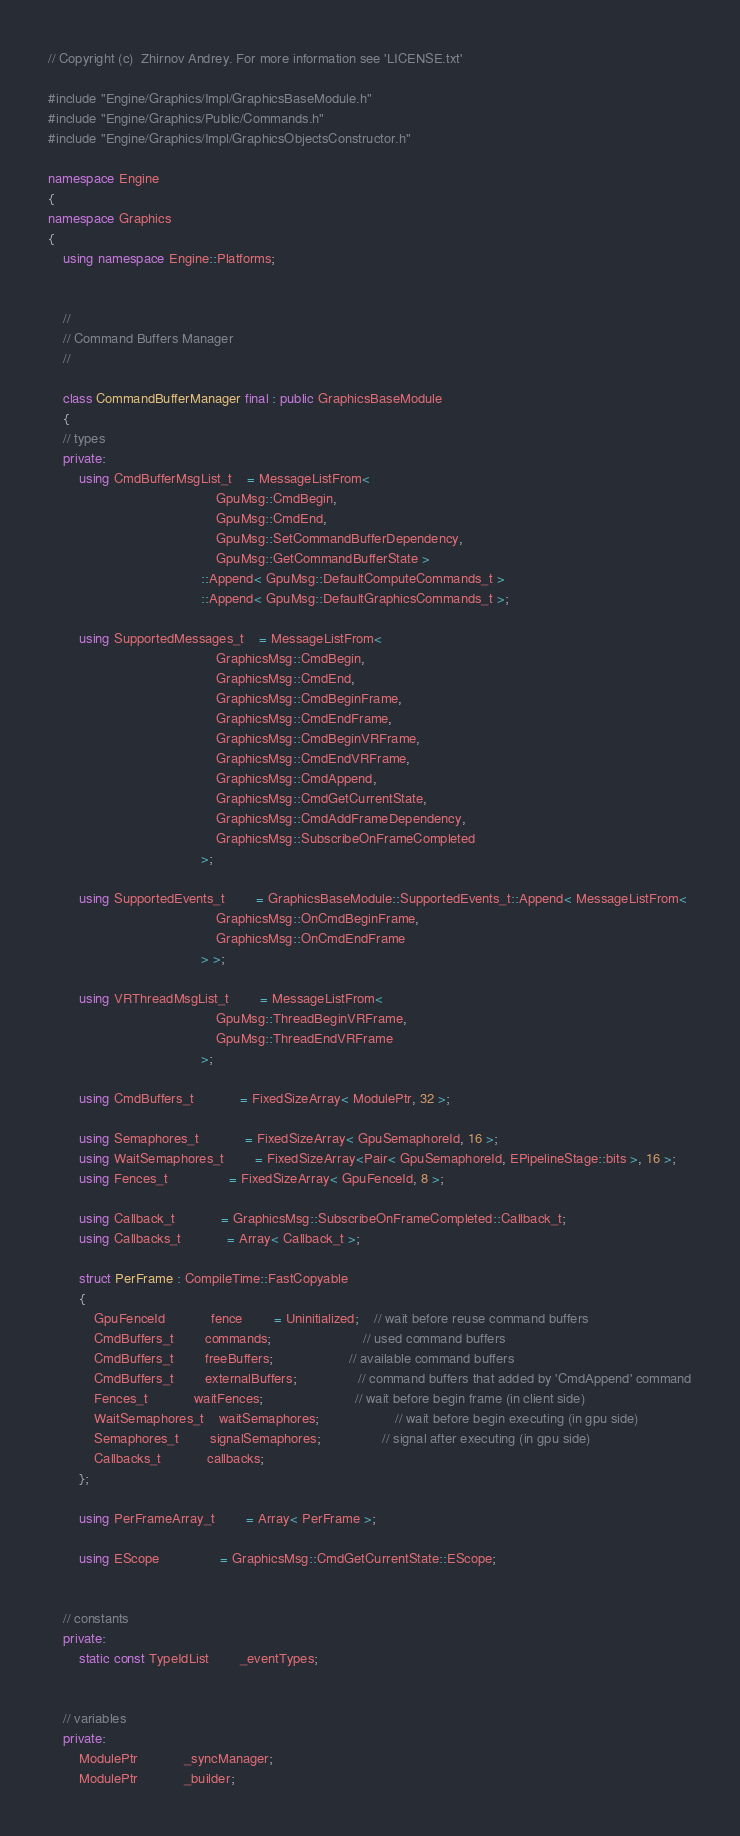<code> <loc_0><loc_0><loc_500><loc_500><_C++_>// Copyright (c)  Zhirnov Andrey. For more information see 'LICENSE.txt'

#include "Engine/Graphics/Impl/GraphicsBaseModule.h"
#include "Engine/Graphics/Public/Commands.h"
#include "Engine/Graphics/Impl/GraphicsObjectsConstructor.h"

namespace Engine
{
namespace Graphics
{
	using namespace Engine::Platforms;


	//
	// Command Buffers Manager
	//

	class CommandBufferManager final : public GraphicsBaseModule
	{
	// types
	private:
		using CmdBufferMsgList_t	= MessageListFrom<
											GpuMsg::CmdBegin,
											GpuMsg::CmdEnd,
											GpuMsg::SetCommandBufferDependency,
											GpuMsg::GetCommandBufferState >
										::Append< GpuMsg::DefaultComputeCommands_t >
										::Append< GpuMsg::DefaultGraphicsCommands_t >;
		
		using SupportedMessages_t	= MessageListFrom<
											GraphicsMsg::CmdBegin,
											GraphicsMsg::CmdEnd,
											GraphicsMsg::CmdBeginFrame,
											GraphicsMsg::CmdEndFrame,
											GraphicsMsg::CmdBeginVRFrame,
											GraphicsMsg::CmdEndVRFrame,
											GraphicsMsg::CmdAppend,
											GraphicsMsg::CmdGetCurrentState,
											GraphicsMsg::CmdAddFrameDependency,
											GraphicsMsg::SubscribeOnFrameCompleted
										>;

		using SupportedEvents_t		= GraphicsBaseModule::SupportedEvents_t::Append< MessageListFrom<
											GraphicsMsg::OnCmdBeginFrame,
											GraphicsMsg::OnCmdEndFrame
										> >;

		using VRThreadMsgList_t		= MessageListFrom<
											GpuMsg::ThreadBeginVRFrame,
											GpuMsg::ThreadEndVRFrame
										>;

		using CmdBuffers_t			= FixedSizeArray< ModulePtr, 32 >;

		using Semaphores_t			= FixedSizeArray< GpuSemaphoreId, 16 >;
		using WaitSemaphores_t		= FixedSizeArray<Pair< GpuSemaphoreId, EPipelineStage::bits >, 16 >;
		using Fences_t				= FixedSizeArray< GpuFenceId, 8 >;

		using Callback_t			= GraphicsMsg::SubscribeOnFrameCompleted::Callback_t;
		using Callbacks_t			= Array< Callback_t >;

		struct PerFrame : CompileTime::FastCopyable
		{
			GpuFenceId			fence		= Uninitialized;	// wait before reuse command buffers
			CmdBuffers_t		commands;						// used command buffers
			CmdBuffers_t		freeBuffers;					// available command buffers
			CmdBuffers_t		externalBuffers;				// command buffers that added by 'CmdAppend' command
			Fences_t			waitFences;						// wait before begin frame (in client side)
			WaitSemaphores_t	waitSemaphores;					// wait before begin executing (in gpu side)
			Semaphores_t		signalSemaphores;				// signal after executing (in gpu side)
			Callbacks_t			callbacks;
		};

		using PerFrameArray_t		= Array< PerFrame >;

		using EScope				= GraphicsMsg::CmdGetCurrentState::EScope;


	// constants
	private:
		static const TypeIdList		_eventTypes;


	// variables
	private:
		ModulePtr			_syncManager;
		ModulePtr			_builder;</code> 